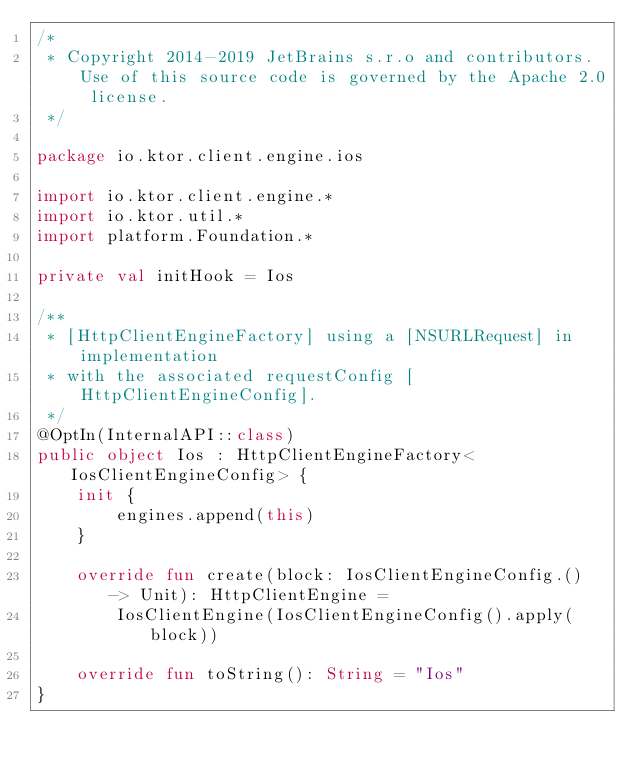Convert code to text. <code><loc_0><loc_0><loc_500><loc_500><_Kotlin_>/*
 * Copyright 2014-2019 JetBrains s.r.o and contributors. Use of this source code is governed by the Apache 2.0 license.
 */

package io.ktor.client.engine.ios

import io.ktor.client.engine.*
import io.ktor.util.*
import platform.Foundation.*

private val initHook = Ios

/**
 * [HttpClientEngineFactory] using a [NSURLRequest] in implementation
 * with the associated requestConfig [HttpClientEngineConfig].
 */
@OptIn(InternalAPI::class)
public object Ios : HttpClientEngineFactory<IosClientEngineConfig> {
    init {
        engines.append(this)
    }

    override fun create(block: IosClientEngineConfig.() -> Unit): HttpClientEngine =
        IosClientEngine(IosClientEngineConfig().apply(block))

    override fun toString(): String = "Ios"
}
</code> 